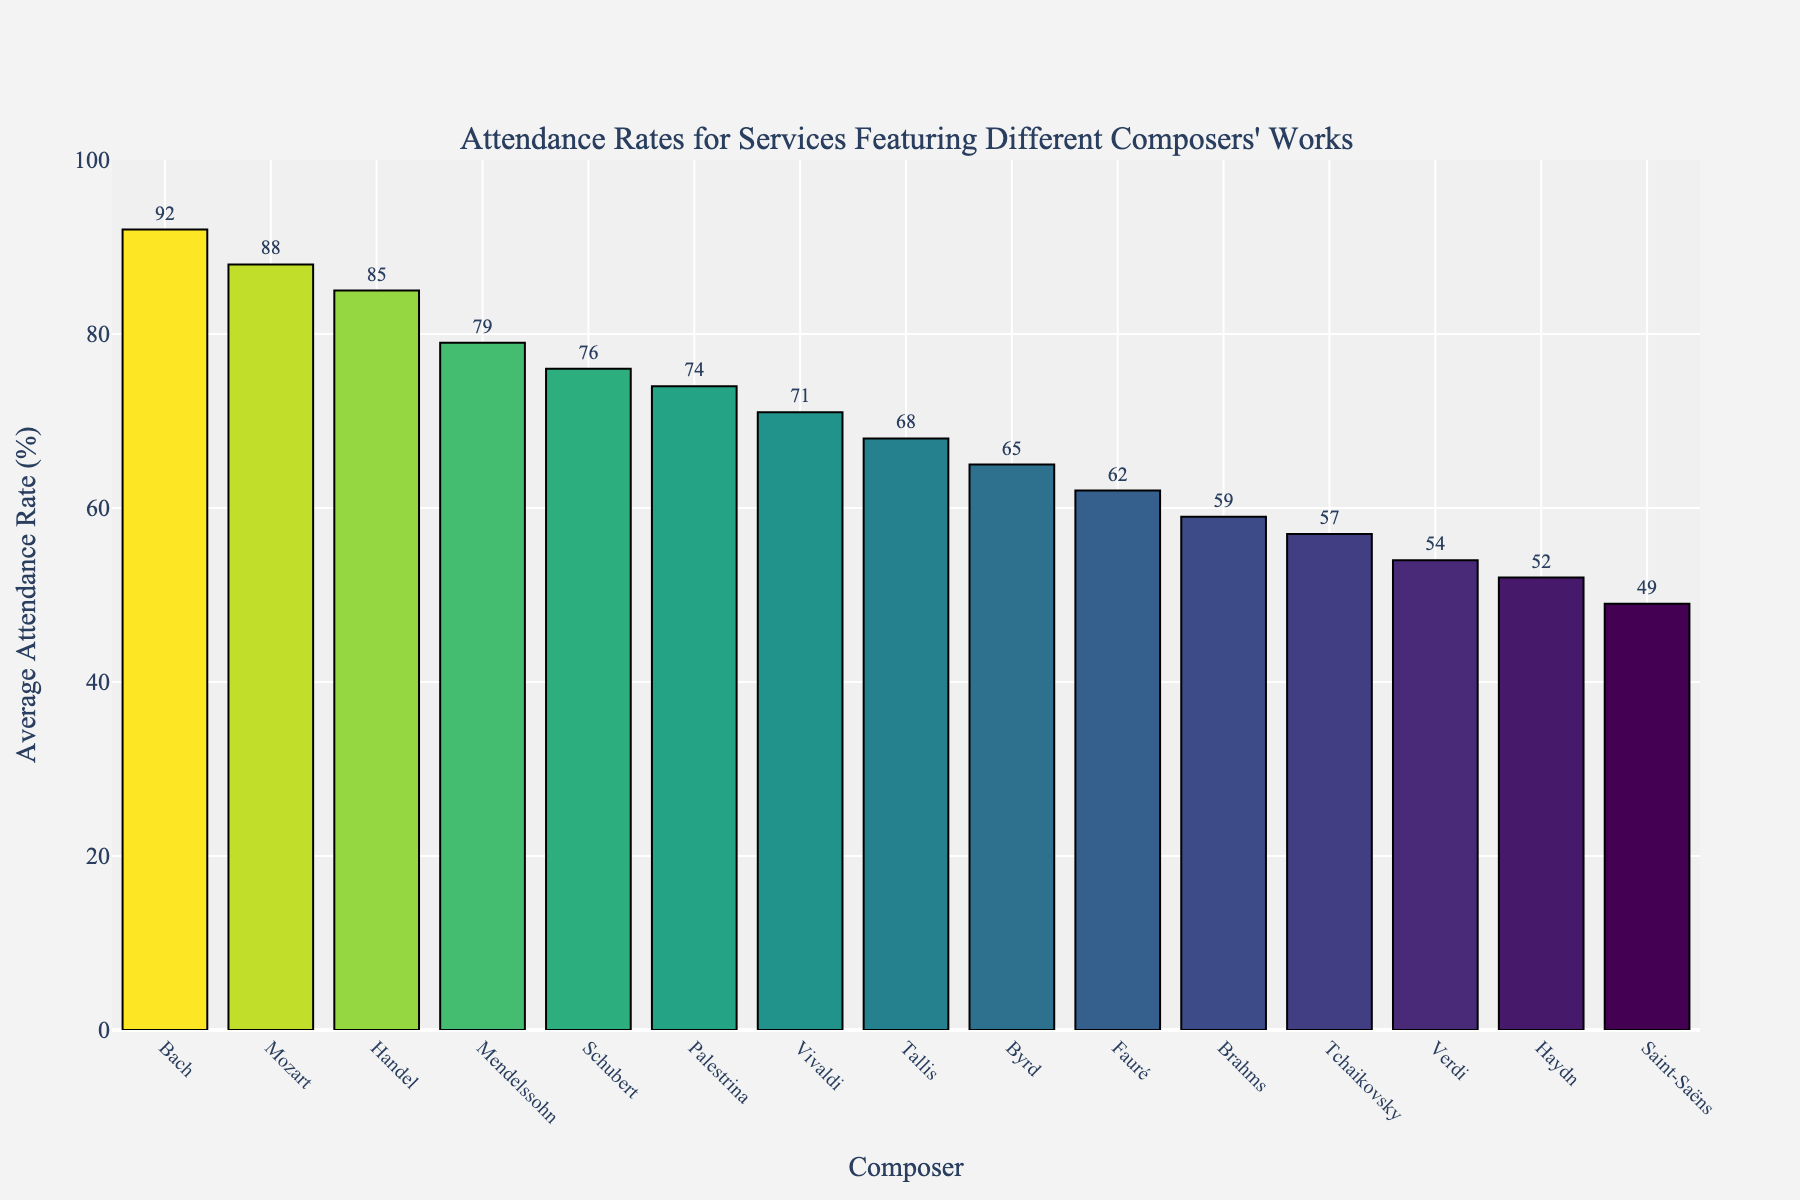What's the highest attendance rate among the composers? The bar that represents Bach reaches the highest point on the y-axis at 92%.
Answer: 92% Which composer has the lowest attendance rate, and what is it? Saint-Saëns has the lowest bar, indicating the lowest attendance rate at 49%.
Answer: Saint-Saëns, 49% Which two composers have attendance rates closest to each other? Verdi and Haydn have attendance rates that are very close. Verdi has 54% and Haydn has 52%, which are only 2% apart.
Answer: Verdi and Haydn What's the difference in attendance rates between Bach and Fauré? Bach has an attendance rate of 92%, while Fauré has 62%. The difference is 92% - 62% = 30%.
Answer: 30% Which composer's attendance rate is exactly in the middle when the composers are ranked from highest to lowest attendance rates? Given the sorted list, Palestrina is in the middle with an attendance rate of 74%.
Answer: Palestrina, 74% What's the combined average attendance rate for the top three composers? The top three composers are Bach (92%), Mozart (88%), and Handel (85%). The combined average is (92 + 88 + 85) / 3 = 88.33%.
Answer: 88.33% Which composers have attendance rates above 80%? The composers with attendance rates above 80% are Bach (92%), Mozart (88%), and Handel (85%).
Answer: Bach, Mozart, and Handel Compare the attendance rates of the Baroque composers (Bach, Handel, Vivaldi) and the Classical composers (Mozart, Haydn). Which group has a higher average attendance rate? The average for Baroque composers is (92 + 85 + 71) / 3 = 82.67%. The average for Classical composers is (88 + 52) / 2 = 70%. The Baroque group has a higher average attendance rate.
Answer: Baroque What's the percentage difference between Mendelssohn and Schubert? Mendelssohn's rate is 79%, and Schubert's is 76%. The percentage difference is ((79 - 76) / 79) * 100 = 3.8%.
Answer: 3.8% 